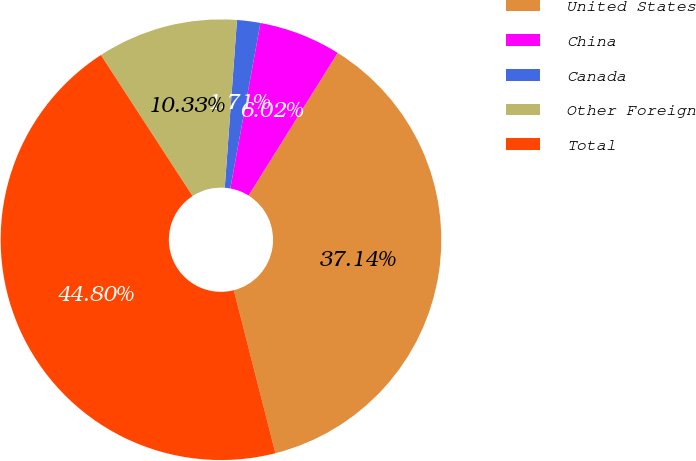Convert chart to OTSL. <chart><loc_0><loc_0><loc_500><loc_500><pie_chart><fcel>United States<fcel>China<fcel>Canada<fcel>Other Foreign<fcel>Total<nl><fcel>37.14%<fcel>6.02%<fcel>1.71%<fcel>10.33%<fcel>44.8%<nl></chart> 